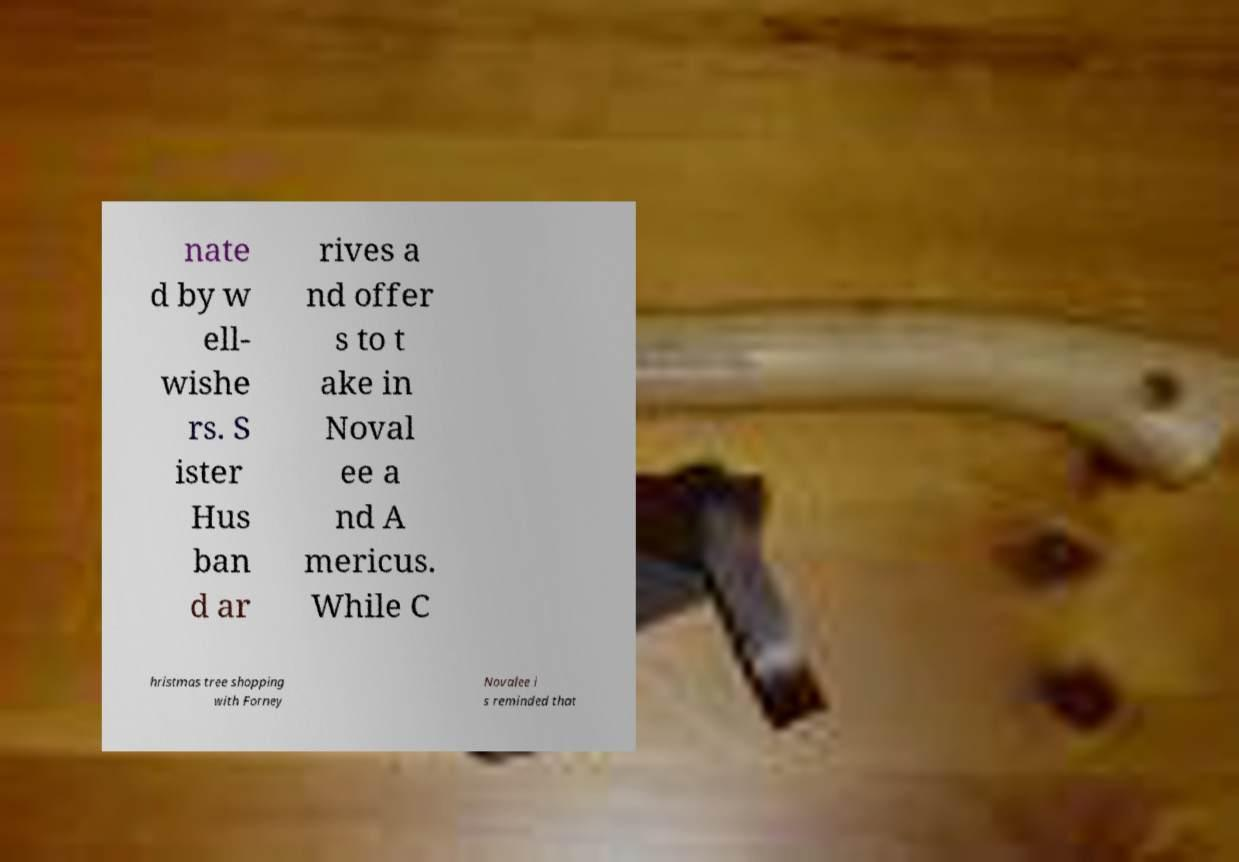Can you accurately transcribe the text from the provided image for me? nate d by w ell- wishe rs. S ister Hus ban d ar rives a nd offer s to t ake in Noval ee a nd A mericus. While C hristmas tree shopping with Forney Novalee i s reminded that 